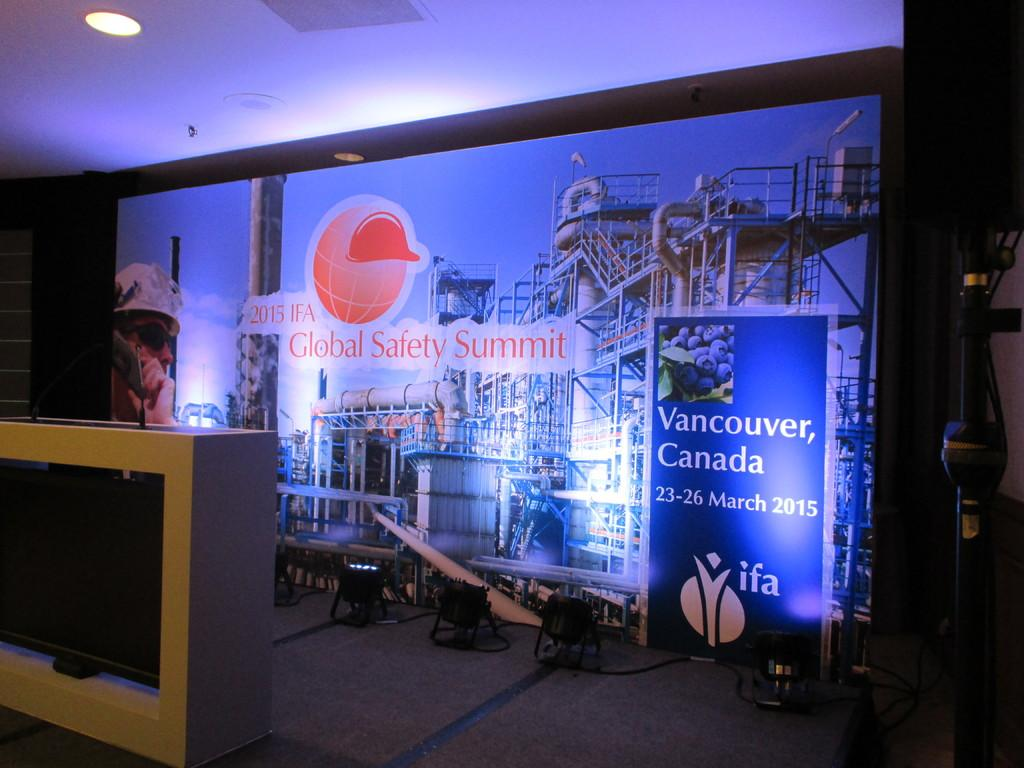<image>
Give a short and clear explanation of the subsequent image. a large wall that has a poster that says 'vancouver, canada' on it 